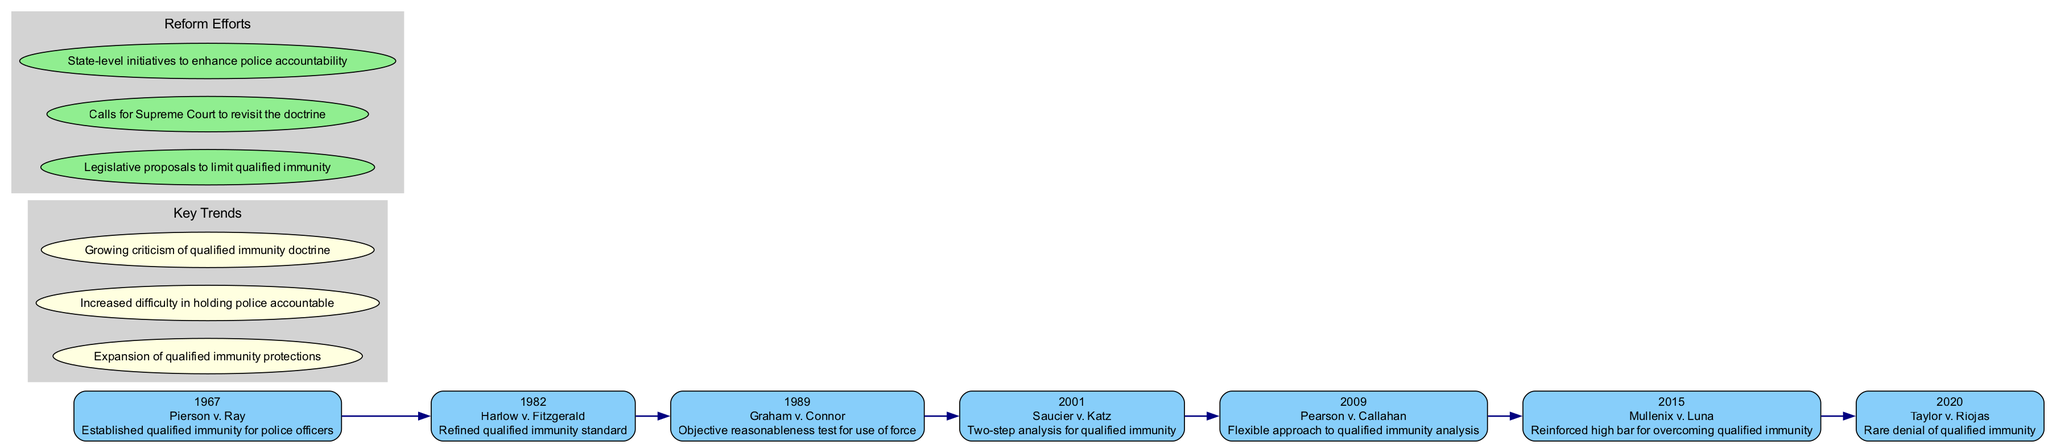What year was the case "Graham v. Connor" decided? The timeline shows the year associated with the case "Graham v. Connor," which is specifically marked with the year 1989.
Answer: 1989 Which case established qualified immunity for police officers? By looking at the timeline, it indicates that "Pierson v. Ray" is the case that established qualified immunity, as pointed out in the significance section.
Answer: Pierson v. Ray How many total landmark Supreme Court cases are shown in the timeline? The timeline lists a total of seven cases, as each case is represented as a separate node with its own year and significance.
Answer: 7 What key trend involves increased difficulty in holding police accountable? The key trend listed in the diagram specifically mentions "Increased difficulty in holding police accountable," which can be directly read from the section on key trends.
Answer: Increased difficulty in holding police accountable What is the significance of the case "Pearson v. Callahan"? The significance provided for the case "Pearson v. Callahan," listed in the timeline, states that it pertains to a "Flexible approach to qualified immunity analysis," reflecting its importance in the context of qualified immunity.
Answer: Flexible approach to qualified immunity analysis In which year was the case "Mullenix v. Luna" decided? The timeline indicates that the year of "Mullenix v. Luna" is listed as 2015, making it easy to find by following the structure of the diagram.
Answer: 2015 What do the nodes labeled "Legislative proposals to limit qualified immunity" represent in the diagram? The nodes labeled with such phrases represent the reform efforts aimed at addressing police accountability issues, which can be found in the reform efforts section of the diagram.
Answer: Reform efforts Which case, decided in 2020, represents a rare denial of qualified immunity? The timeline clearly denotes "Taylor v. Riojas," decided in 2020, as the notable case representing a rare denial of qualified immunity, as reflected in its significance.
Answer: Taylor v. Riojas What is the central theme of the key trends discussed in this diagram? By reviewing the key trends, the central theme is the criticism and expansion of qualified immunity protections, as it highlights both the expansion and the backlash against the doctrine.
Answer: Criticism of qualified immunity doctrine 